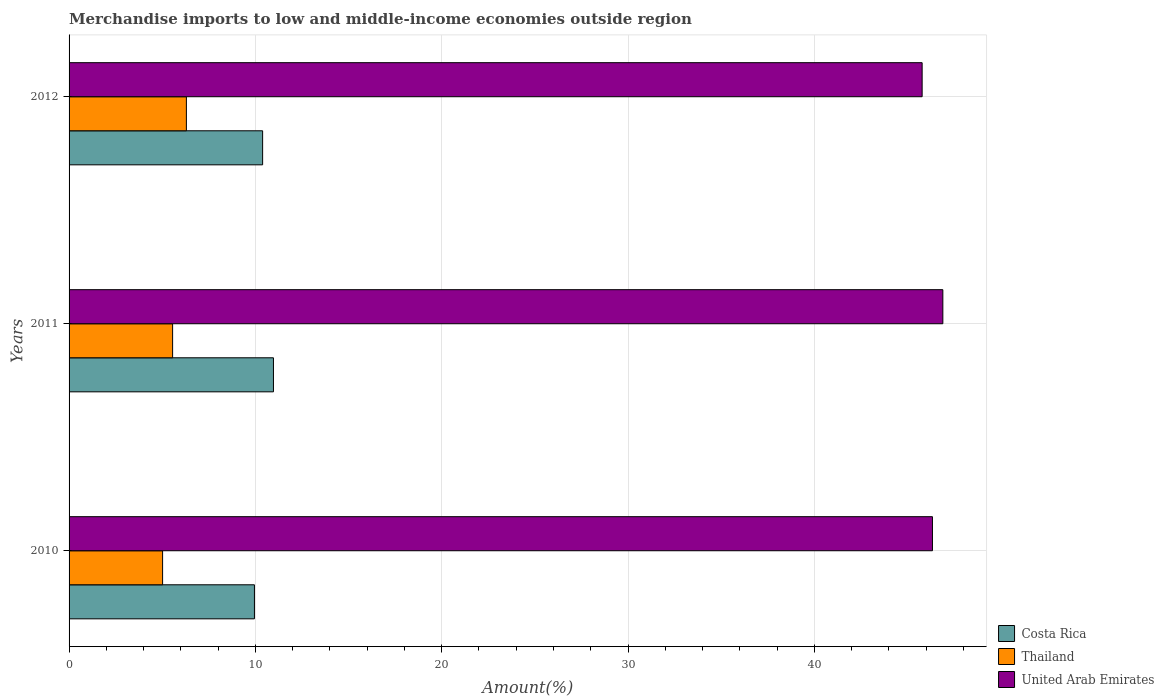How many different coloured bars are there?
Offer a terse response. 3. Are the number of bars per tick equal to the number of legend labels?
Your response must be concise. Yes. Are the number of bars on each tick of the Y-axis equal?
Ensure brevity in your answer.  Yes. How many bars are there on the 2nd tick from the top?
Your answer should be compact. 3. What is the label of the 1st group of bars from the top?
Offer a terse response. 2012. In how many cases, is the number of bars for a given year not equal to the number of legend labels?
Provide a short and direct response. 0. What is the percentage of amount earned from merchandise imports in Costa Rica in 2012?
Your answer should be compact. 10.39. Across all years, what is the maximum percentage of amount earned from merchandise imports in Thailand?
Offer a very short reply. 6.3. Across all years, what is the minimum percentage of amount earned from merchandise imports in Thailand?
Provide a short and direct response. 5.02. In which year was the percentage of amount earned from merchandise imports in Thailand maximum?
Give a very brief answer. 2012. What is the total percentage of amount earned from merchandise imports in United Arab Emirates in the graph?
Keep it short and to the point. 139.02. What is the difference between the percentage of amount earned from merchandise imports in Thailand in 2011 and that in 2012?
Provide a short and direct response. -0.74. What is the difference between the percentage of amount earned from merchandise imports in Costa Rica in 2010 and the percentage of amount earned from merchandise imports in Thailand in 2011?
Your response must be concise. 4.39. What is the average percentage of amount earned from merchandise imports in United Arab Emirates per year?
Your answer should be very brief. 46.34. In the year 2011, what is the difference between the percentage of amount earned from merchandise imports in United Arab Emirates and percentage of amount earned from merchandise imports in Costa Rica?
Provide a short and direct response. 35.93. What is the ratio of the percentage of amount earned from merchandise imports in Costa Rica in 2010 to that in 2011?
Offer a terse response. 0.91. Is the percentage of amount earned from merchandise imports in United Arab Emirates in 2010 less than that in 2011?
Provide a short and direct response. Yes. Is the difference between the percentage of amount earned from merchandise imports in United Arab Emirates in 2010 and 2011 greater than the difference between the percentage of amount earned from merchandise imports in Costa Rica in 2010 and 2011?
Your answer should be compact. Yes. What is the difference between the highest and the second highest percentage of amount earned from merchandise imports in Thailand?
Your response must be concise. 0.74. What is the difference between the highest and the lowest percentage of amount earned from merchandise imports in United Arab Emirates?
Provide a short and direct response. 1.11. In how many years, is the percentage of amount earned from merchandise imports in United Arab Emirates greater than the average percentage of amount earned from merchandise imports in United Arab Emirates taken over all years?
Your answer should be very brief. 1. What does the 1st bar from the top in 2010 represents?
Provide a succinct answer. United Arab Emirates. What does the 1st bar from the bottom in 2012 represents?
Provide a succinct answer. Costa Rica. Are all the bars in the graph horizontal?
Keep it short and to the point. Yes. What is the difference between two consecutive major ticks on the X-axis?
Offer a terse response. 10. Are the values on the major ticks of X-axis written in scientific E-notation?
Make the answer very short. No. Does the graph contain any zero values?
Your answer should be compact. No. Where does the legend appear in the graph?
Provide a short and direct response. Bottom right. How are the legend labels stacked?
Your answer should be very brief. Vertical. What is the title of the graph?
Provide a short and direct response. Merchandise imports to low and middle-income economies outside region. Does "Guyana" appear as one of the legend labels in the graph?
Give a very brief answer. No. What is the label or title of the X-axis?
Your answer should be very brief. Amount(%). What is the label or title of the Y-axis?
Offer a terse response. Years. What is the Amount(%) of Costa Rica in 2010?
Offer a terse response. 9.95. What is the Amount(%) of Thailand in 2010?
Your answer should be compact. 5.02. What is the Amount(%) in United Arab Emirates in 2010?
Provide a succinct answer. 46.34. What is the Amount(%) in Costa Rica in 2011?
Offer a very short reply. 10.97. What is the Amount(%) in Thailand in 2011?
Provide a succinct answer. 5.56. What is the Amount(%) in United Arab Emirates in 2011?
Offer a very short reply. 46.9. What is the Amount(%) in Costa Rica in 2012?
Provide a short and direct response. 10.39. What is the Amount(%) in Thailand in 2012?
Provide a succinct answer. 6.3. What is the Amount(%) in United Arab Emirates in 2012?
Ensure brevity in your answer.  45.78. Across all years, what is the maximum Amount(%) in Costa Rica?
Your answer should be very brief. 10.97. Across all years, what is the maximum Amount(%) of Thailand?
Ensure brevity in your answer.  6.3. Across all years, what is the maximum Amount(%) of United Arab Emirates?
Ensure brevity in your answer.  46.9. Across all years, what is the minimum Amount(%) in Costa Rica?
Offer a terse response. 9.95. Across all years, what is the minimum Amount(%) of Thailand?
Offer a very short reply. 5.02. Across all years, what is the minimum Amount(%) in United Arab Emirates?
Ensure brevity in your answer.  45.78. What is the total Amount(%) of Costa Rica in the graph?
Provide a short and direct response. 31.31. What is the total Amount(%) of Thailand in the graph?
Your answer should be very brief. 16.87. What is the total Amount(%) in United Arab Emirates in the graph?
Offer a terse response. 139.02. What is the difference between the Amount(%) of Costa Rica in 2010 and that in 2011?
Ensure brevity in your answer.  -1.02. What is the difference between the Amount(%) in Thailand in 2010 and that in 2011?
Provide a short and direct response. -0.54. What is the difference between the Amount(%) of United Arab Emirates in 2010 and that in 2011?
Your answer should be very brief. -0.56. What is the difference between the Amount(%) of Costa Rica in 2010 and that in 2012?
Your answer should be very brief. -0.44. What is the difference between the Amount(%) in Thailand in 2010 and that in 2012?
Ensure brevity in your answer.  -1.28. What is the difference between the Amount(%) in United Arab Emirates in 2010 and that in 2012?
Your answer should be compact. 0.55. What is the difference between the Amount(%) of Costa Rica in 2011 and that in 2012?
Make the answer very short. 0.58. What is the difference between the Amount(%) in Thailand in 2011 and that in 2012?
Give a very brief answer. -0.74. What is the difference between the Amount(%) in United Arab Emirates in 2011 and that in 2012?
Keep it short and to the point. 1.11. What is the difference between the Amount(%) in Costa Rica in 2010 and the Amount(%) in Thailand in 2011?
Provide a succinct answer. 4.39. What is the difference between the Amount(%) in Costa Rica in 2010 and the Amount(%) in United Arab Emirates in 2011?
Your answer should be very brief. -36.95. What is the difference between the Amount(%) of Thailand in 2010 and the Amount(%) of United Arab Emirates in 2011?
Offer a terse response. -41.88. What is the difference between the Amount(%) of Costa Rica in 2010 and the Amount(%) of Thailand in 2012?
Provide a succinct answer. 3.65. What is the difference between the Amount(%) of Costa Rica in 2010 and the Amount(%) of United Arab Emirates in 2012?
Make the answer very short. -35.84. What is the difference between the Amount(%) of Thailand in 2010 and the Amount(%) of United Arab Emirates in 2012?
Give a very brief answer. -40.77. What is the difference between the Amount(%) in Costa Rica in 2011 and the Amount(%) in Thailand in 2012?
Offer a very short reply. 4.67. What is the difference between the Amount(%) in Costa Rica in 2011 and the Amount(%) in United Arab Emirates in 2012?
Your answer should be compact. -34.81. What is the difference between the Amount(%) in Thailand in 2011 and the Amount(%) in United Arab Emirates in 2012?
Your response must be concise. -40.23. What is the average Amount(%) in Costa Rica per year?
Offer a terse response. 10.44. What is the average Amount(%) of Thailand per year?
Your answer should be very brief. 5.62. What is the average Amount(%) of United Arab Emirates per year?
Make the answer very short. 46.34. In the year 2010, what is the difference between the Amount(%) of Costa Rica and Amount(%) of Thailand?
Ensure brevity in your answer.  4.93. In the year 2010, what is the difference between the Amount(%) in Costa Rica and Amount(%) in United Arab Emirates?
Your answer should be compact. -36.39. In the year 2010, what is the difference between the Amount(%) of Thailand and Amount(%) of United Arab Emirates?
Offer a very short reply. -41.32. In the year 2011, what is the difference between the Amount(%) in Costa Rica and Amount(%) in Thailand?
Provide a short and direct response. 5.41. In the year 2011, what is the difference between the Amount(%) of Costa Rica and Amount(%) of United Arab Emirates?
Keep it short and to the point. -35.93. In the year 2011, what is the difference between the Amount(%) of Thailand and Amount(%) of United Arab Emirates?
Offer a very short reply. -41.34. In the year 2012, what is the difference between the Amount(%) in Costa Rica and Amount(%) in Thailand?
Provide a succinct answer. 4.09. In the year 2012, what is the difference between the Amount(%) of Costa Rica and Amount(%) of United Arab Emirates?
Provide a succinct answer. -35.4. In the year 2012, what is the difference between the Amount(%) of Thailand and Amount(%) of United Arab Emirates?
Give a very brief answer. -39.49. What is the ratio of the Amount(%) of Costa Rica in 2010 to that in 2011?
Offer a very short reply. 0.91. What is the ratio of the Amount(%) of Thailand in 2010 to that in 2011?
Your answer should be very brief. 0.9. What is the ratio of the Amount(%) of Costa Rica in 2010 to that in 2012?
Give a very brief answer. 0.96. What is the ratio of the Amount(%) in Thailand in 2010 to that in 2012?
Provide a short and direct response. 0.8. What is the ratio of the Amount(%) of United Arab Emirates in 2010 to that in 2012?
Offer a terse response. 1.01. What is the ratio of the Amount(%) of Costa Rica in 2011 to that in 2012?
Give a very brief answer. 1.06. What is the ratio of the Amount(%) in Thailand in 2011 to that in 2012?
Offer a terse response. 0.88. What is the ratio of the Amount(%) of United Arab Emirates in 2011 to that in 2012?
Keep it short and to the point. 1.02. What is the difference between the highest and the second highest Amount(%) of Costa Rica?
Make the answer very short. 0.58. What is the difference between the highest and the second highest Amount(%) of Thailand?
Provide a short and direct response. 0.74. What is the difference between the highest and the second highest Amount(%) in United Arab Emirates?
Provide a succinct answer. 0.56. What is the difference between the highest and the lowest Amount(%) of Costa Rica?
Ensure brevity in your answer.  1.02. What is the difference between the highest and the lowest Amount(%) in Thailand?
Give a very brief answer. 1.28. What is the difference between the highest and the lowest Amount(%) of United Arab Emirates?
Give a very brief answer. 1.11. 